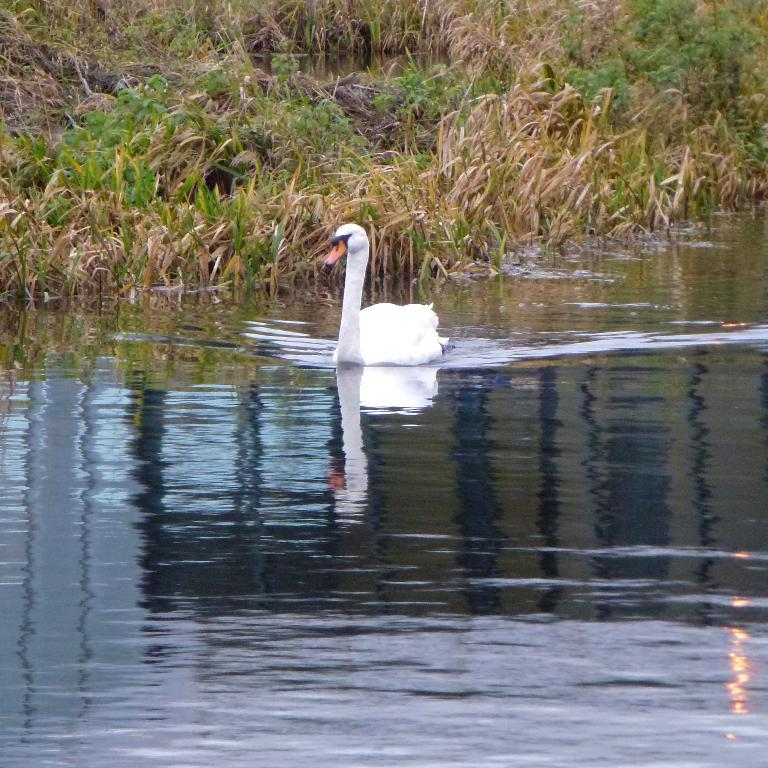What is the main subject in the middle of the image? There is a swan in the middle of the image. Where is the swan located? The swan is on the water. What type of vegetation can be seen at the top of the image? There is grass visible at the top of the image, and there are also plants on the ground. Can you tell me how many kettles are visible in the image? There are no kettles present in the image. What type of cable can be seen connecting the swan to the plants? There is no cable visible in the image; the swan is on the water, and the plants are on the ground. 